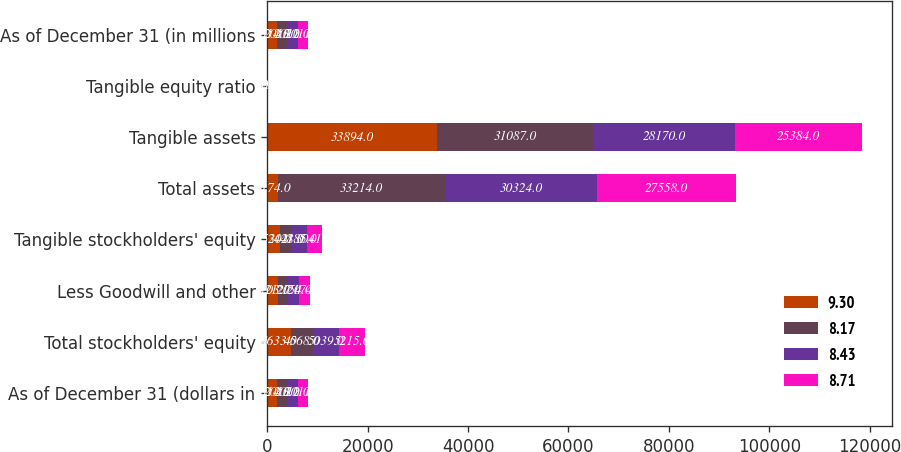Convert chart to OTSL. <chart><loc_0><loc_0><loc_500><loc_500><stacked_bar_chart><ecel><fcel>As of December 31 (dollars in<fcel>Total stockholders' equity<fcel>Less Goodwill and other<fcel>Tangible stockholders' equity<fcel>Total assets<fcel>Tangible assets<fcel>Tangible equity ratio<fcel>As of December 31 (in millions<nl><fcel>9.3<fcel>2014<fcel>4633<fcel>2103<fcel>2530<fcel>2174<fcel>33894<fcel>7.5<fcel>2014<nl><fcel>8.17<fcel>2013<fcel>4568<fcel>2127<fcel>2441<fcel>33214<fcel>31087<fcel>7.9<fcel>2013<nl><fcel>8.43<fcel>2012<fcel>5039<fcel>2154<fcel>2885<fcel>30324<fcel>28170<fcel>10.2<fcel>2012<nl><fcel>8.71<fcel>2011<fcel>5215<fcel>2174<fcel>3041<fcel>27558<fcel>25384<fcel>12<fcel>2011<nl></chart> 